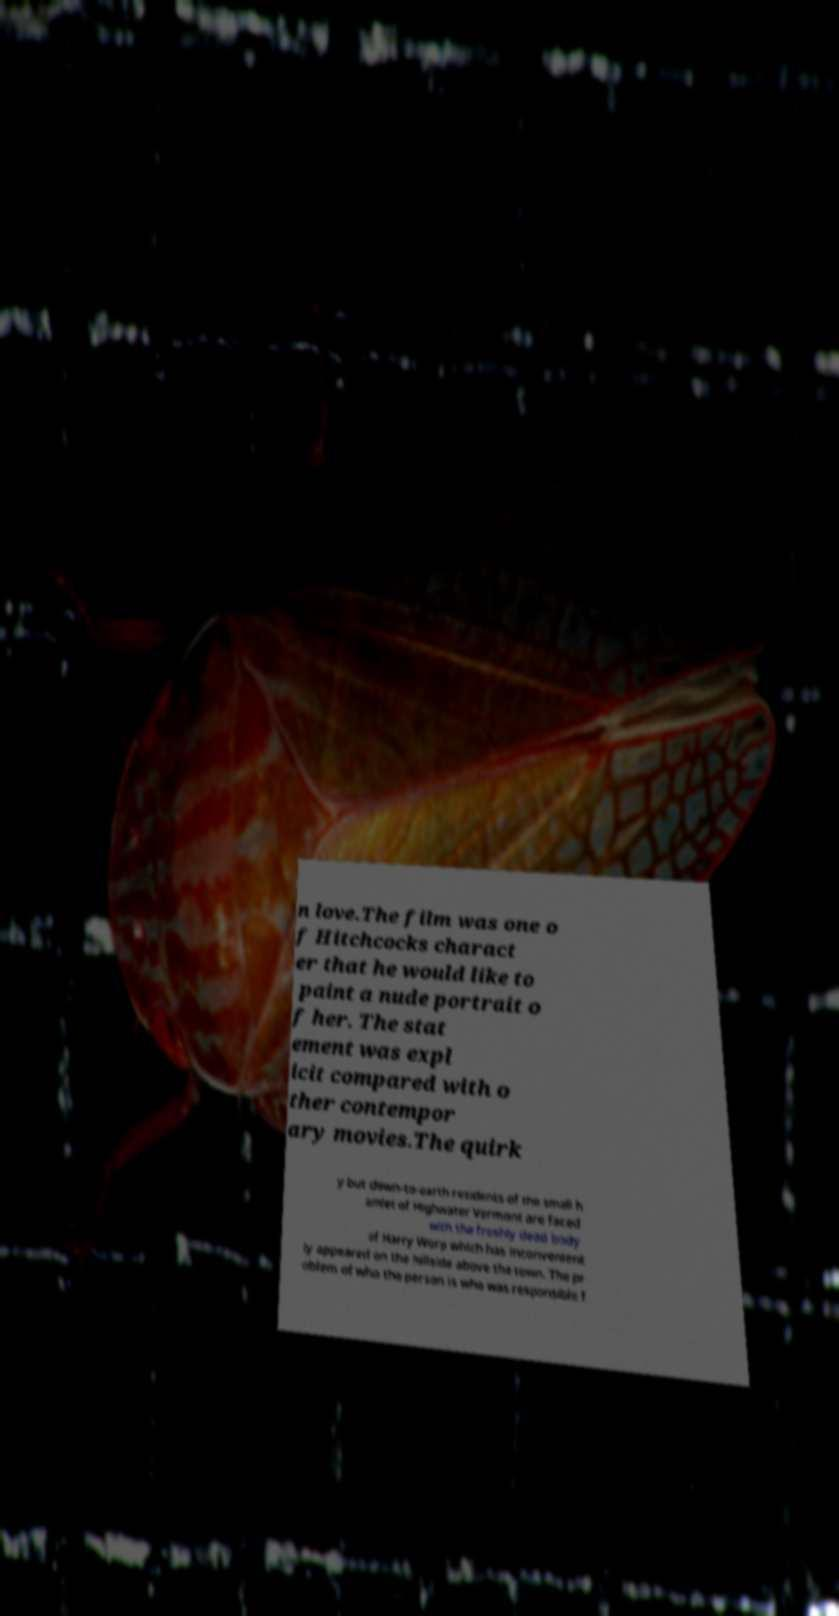Can you read and provide the text displayed in the image?This photo seems to have some interesting text. Can you extract and type it out for me? n love.The film was one o f Hitchcocks charact er that he would like to paint a nude portrait o f her. The stat ement was expl icit compared with o ther contempor ary movies.The quirk y but down-to-earth residents of the small h amlet of Highwater Vermont are faced with the freshly dead body of Harry Worp which has inconvenient ly appeared on the hillside above the town. The pr oblem of who the person is who was responsible f 